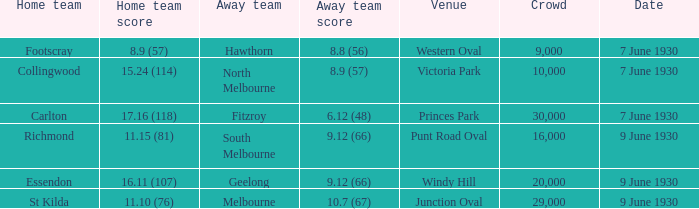What is the tiniest gathering to witness the away team achieve 1 29000.0. 